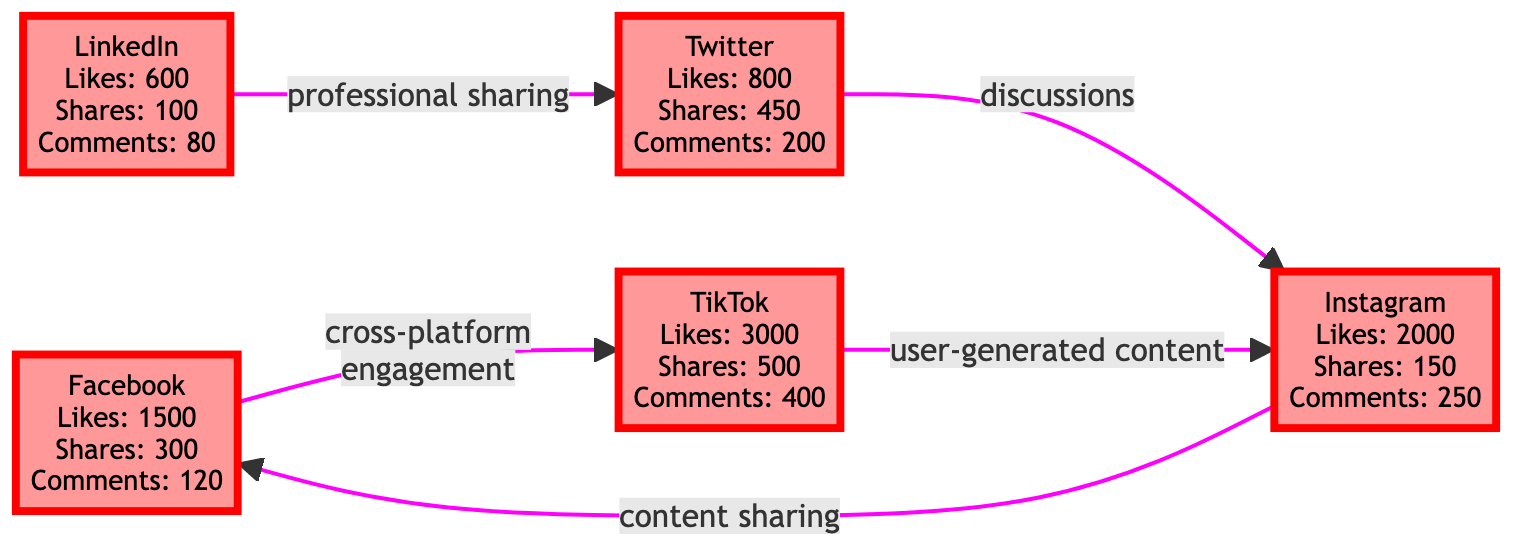What is the total number of platforms represented in this diagram? There are five nodes representing platforms: Facebook, Instagram, Twitter, LinkedIn, and TikTok. So, the total number of platforms is 5.
Answer: 5 Which platform has the most likes? TikTok has the highest number of likes, with a total of 3000 likes.
Answer: TikTok What interaction exists between Twitter and Instagram? The diagram shows that the interaction between Twitter and Instagram is "discussions."
Answer: discussions How many shares did LinkedIn receive? According to the diagram, LinkedIn received a total of 100 shares.
Answer: 100 Which two platforms have a direct engagement link to TikTok? The platforms with direct engagement links to TikTok are Facebook and Instagram.
Answer: Facebook and Instagram What is the total number of comments across all platforms? Adding the comments from all platforms: 120 (Facebook) + 250 (Instagram) + 200 (Twitter) + 80 (LinkedIn) + 400 (TikTok) gives a total of 1050 comments.
Answer: 1050 How many edges are displayed in this diagram? The diagram shows a total of 5 edges connecting the platforms based on various interactions.
Answer: 5 Which platform has the least interactions? LinkedIn has the least interactions in terms of likes, shares, and comments, with figures of 600 likes, 100 shares, and 80 comments.
Answer: LinkedIn What kind of engagement exists between Facebook and TikTok? The engagement between Facebook and TikTok is identified as "cross-platform engagement."
Answer: cross-platform engagement 